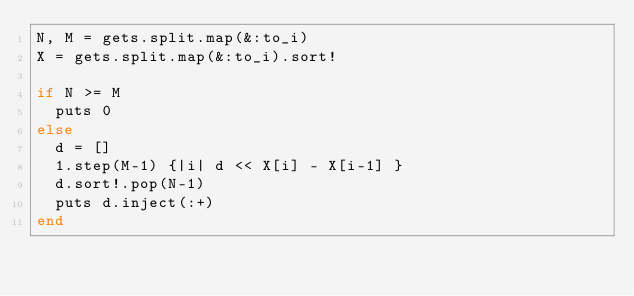<code> <loc_0><loc_0><loc_500><loc_500><_Ruby_>N, M = gets.split.map(&:to_i)
X = gets.split.map(&:to_i).sort!

if N >= M
  puts 0
else
  d = []
  1.step(M-1) {|i| d << X[i] - X[i-1] }
  d.sort!.pop(N-1)
  puts d.inject(:+)
end
</code> 